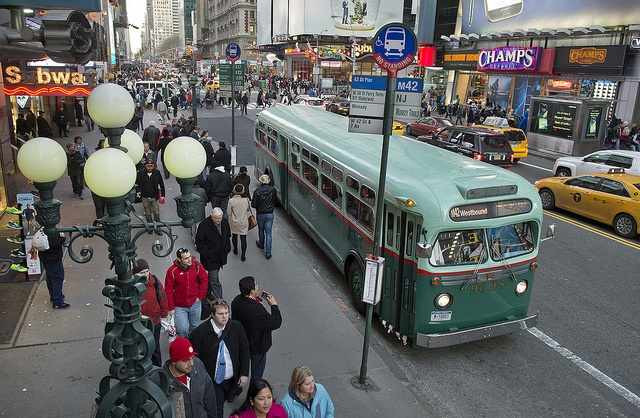Describe the objects in this image and their specific colors. I can see bus in darkblue, black, gray, darkgray, and teal tones, car in darkblue, black, olive, and gray tones, people in darkblue, black, gray, and darkgray tones, people in darkblue, black, gray, and darkgray tones, and people in darkblue, black, gray, and brown tones in this image. 